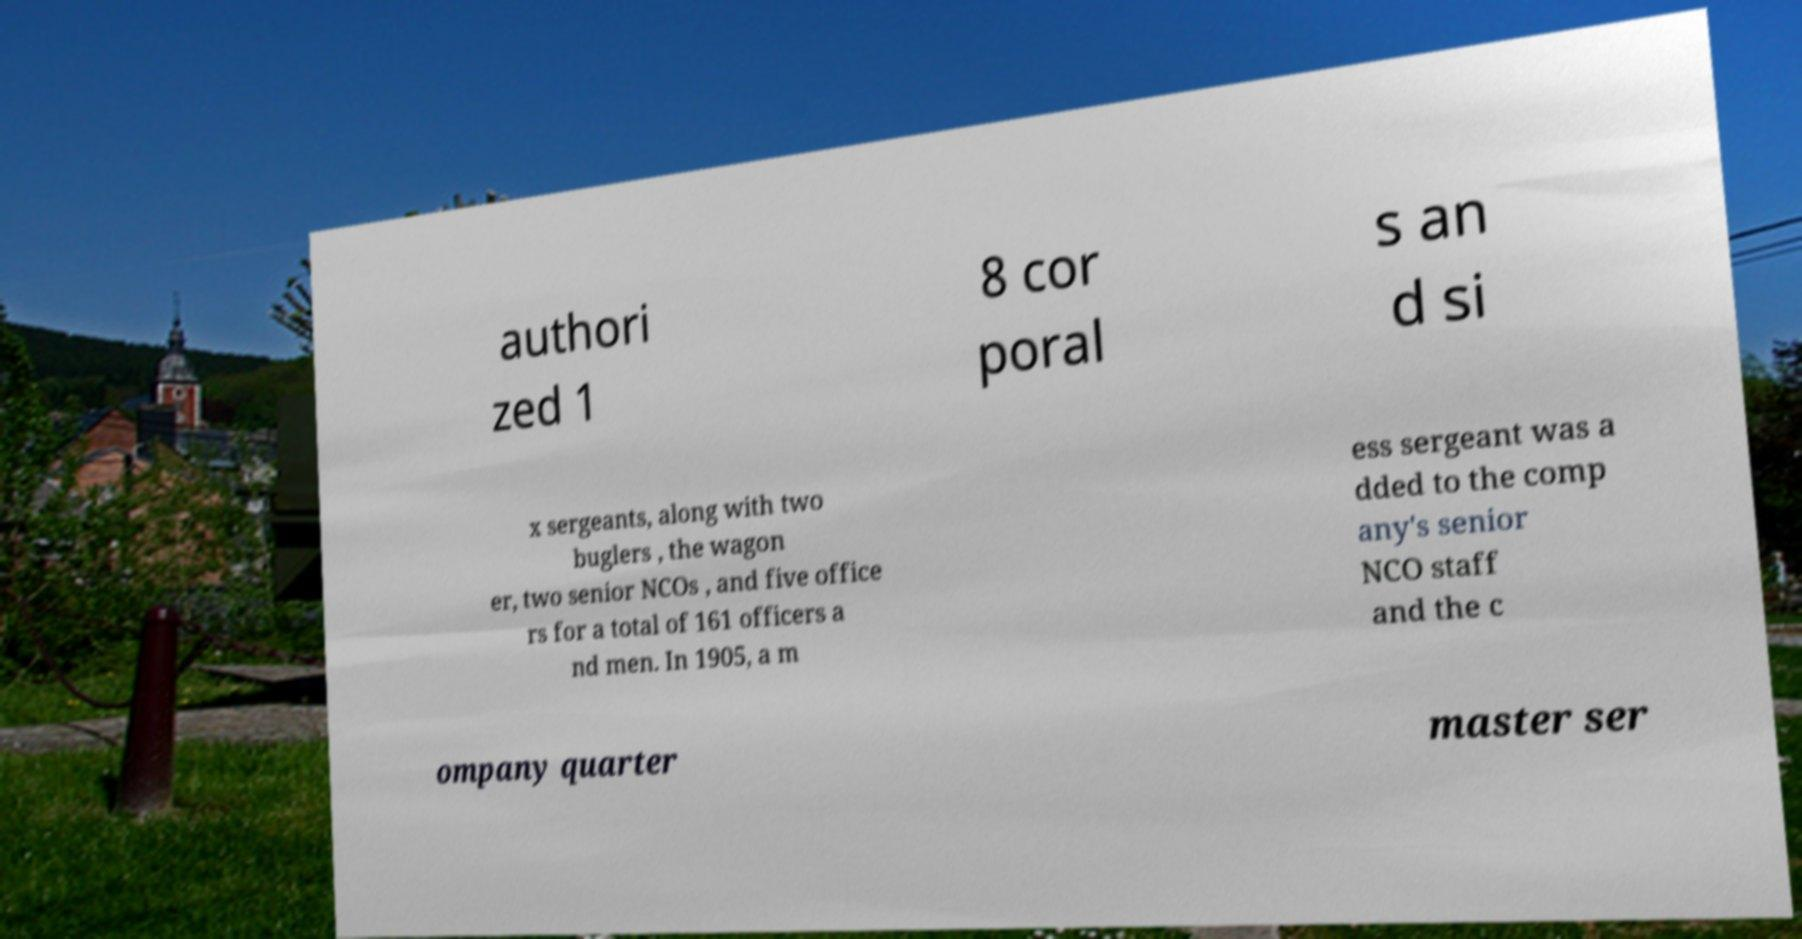For documentation purposes, I need the text within this image transcribed. Could you provide that? authori zed 1 8 cor poral s an d si x sergeants, along with two buglers , the wagon er, two senior NCOs , and five office rs for a total of 161 officers a nd men. In 1905, a m ess sergeant was a dded to the comp any's senior NCO staff and the c ompany quarter master ser 